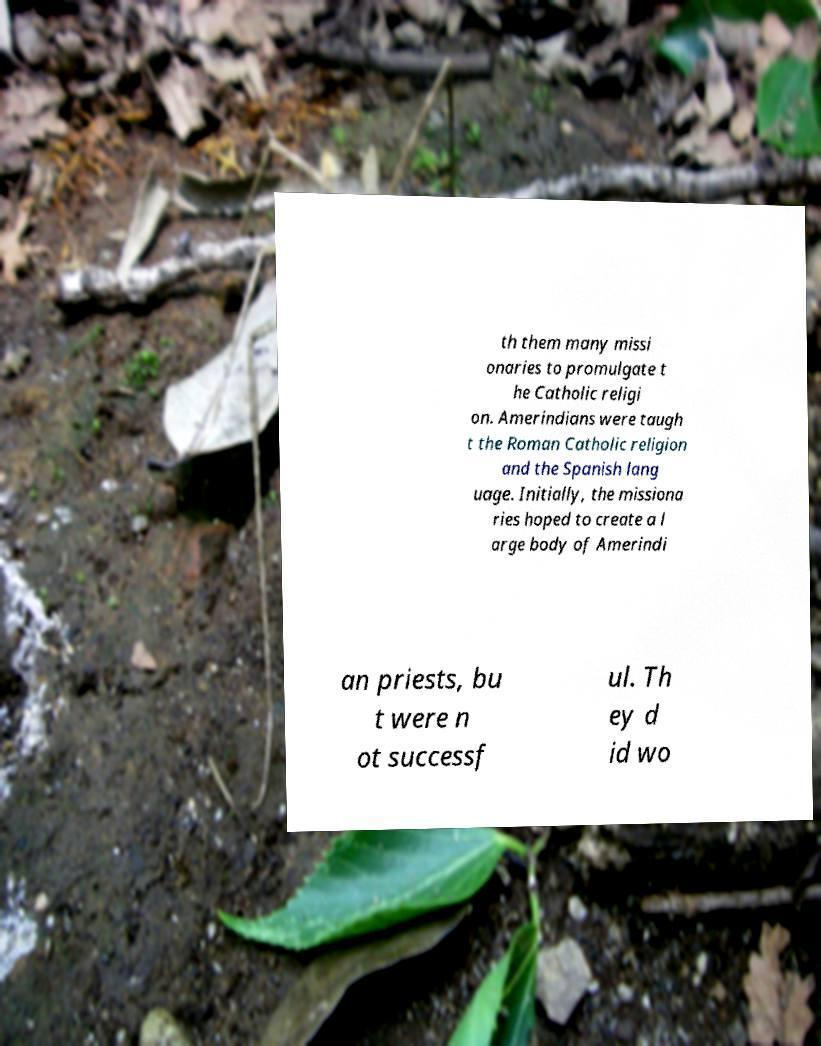There's text embedded in this image that I need extracted. Can you transcribe it verbatim? th them many missi onaries to promulgate t he Catholic religi on. Amerindians were taugh t the Roman Catholic religion and the Spanish lang uage. Initially, the missiona ries hoped to create a l arge body of Amerindi an priests, bu t were n ot successf ul. Th ey d id wo 